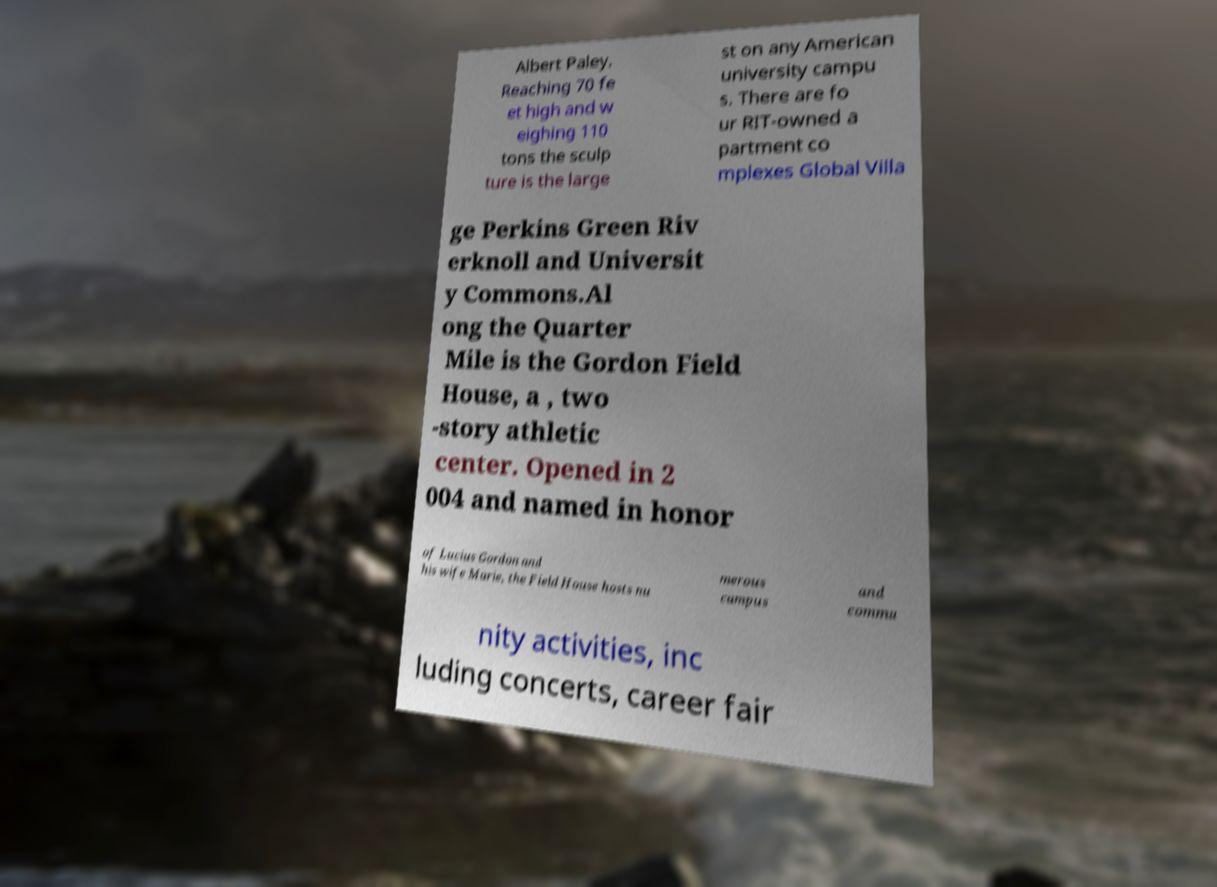I need the written content from this picture converted into text. Can you do that? Albert Paley. Reaching 70 fe et high and w eighing 110 tons the sculp ture is the large st on any American university campu s. There are fo ur RIT-owned a partment co mplexes Global Villa ge Perkins Green Riv erknoll and Universit y Commons.Al ong the Quarter Mile is the Gordon Field House, a , two -story athletic center. Opened in 2 004 and named in honor of Lucius Gordon and his wife Marie, the Field House hosts nu merous campus and commu nity activities, inc luding concerts, career fair 